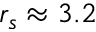Convert formula to latex. <formula><loc_0><loc_0><loc_500><loc_500>r _ { s } \approx 3 . 2</formula> 